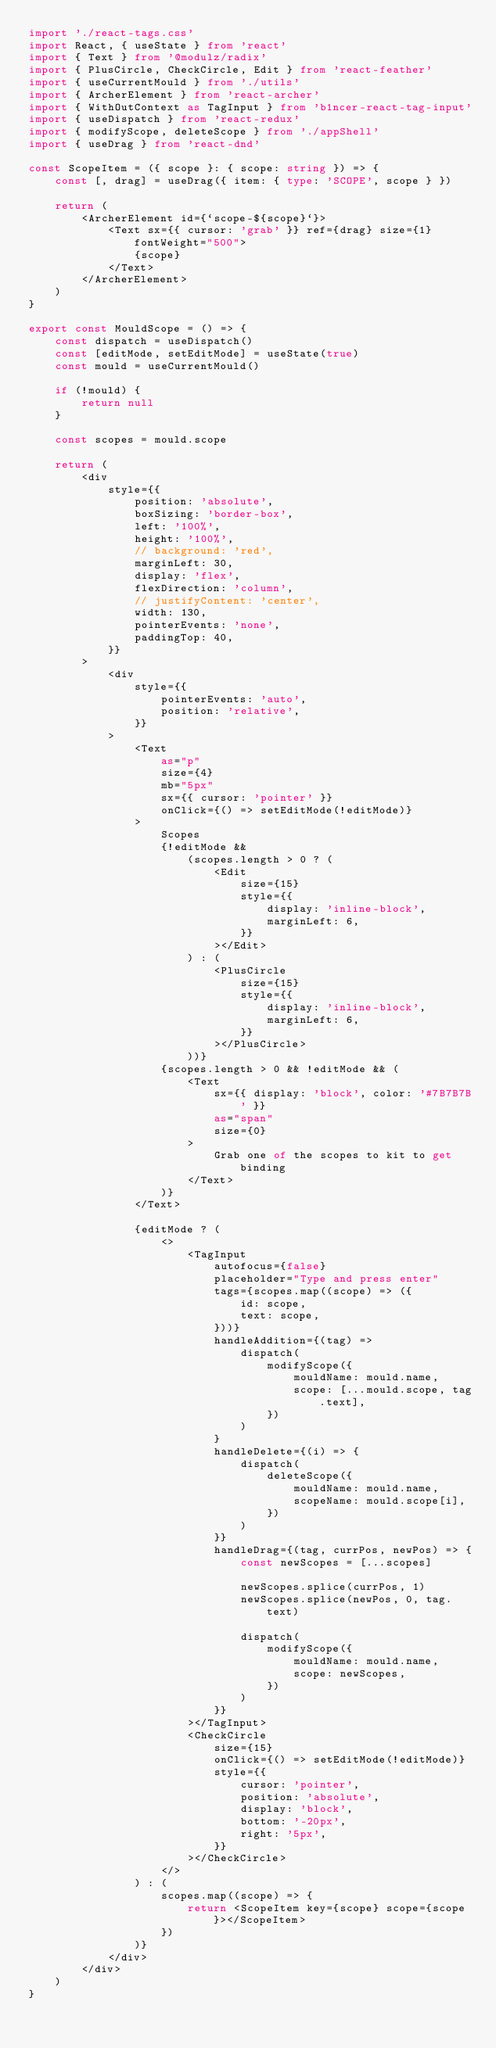<code> <loc_0><loc_0><loc_500><loc_500><_TypeScript_>import './react-tags.css'
import React, { useState } from 'react'
import { Text } from '@modulz/radix'
import { PlusCircle, CheckCircle, Edit } from 'react-feather'
import { useCurrentMould } from './utils'
import { ArcherElement } from 'react-archer'
import { WithOutContext as TagInput } from 'b1ncer-react-tag-input'
import { useDispatch } from 'react-redux'
import { modifyScope, deleteScope } from './appShell'
import { useDrag } from 'react-dnd'

const ScopeItem = ({ scope }: { scope: string }) => {
    const [, drag] = useDrag({ item: { type: 'SCOPE', scope } })

    return (
        <ArcherElement id={`scope-${scope}`}>
            <Text sx={{ cursor: 'grab' }} ref={drag} size={1} fontWeight="500">
                {scope}
            </Text>
        </ArcherElement>
    )
}

export const MouldScope = () => {
    const dispatch = useDispatch()
    const [editMode, setEditMode] = useState(true)
    const mould = useCurrentMould()

    if (!mould) {
        return null
    }

    const scopes = mould.scope

    return (
        <div
            style={{
                position: 'absolute',
                boxSizing: 'border-box',
                left: '100%',
                height: '100%',
                // background: 'red',
                marginLeft: 30,
                display: 'flex',
                flexDirection: 'column',
                // justifyContent: 'center',
                width: 130,
                pointerEvents: 'none',
                paddingTop: 40,
            }}
        >
            <div
                style={{
                    pointerEvents: 'auto',
                    position: 'relative',
                }}
            >
                <Text
                    as="p"
                    size={4}
                    mb="5px"
                    sx={{ cursor: 'pointer' }}
                    onClick={() => setEditMode(!editMode)}
                >
                    Scopes
                    {!editMode &&
                        (scopes.length > 0 ? (
                            <Edit
                                size={15}
                                style={{
                                    display: 'inline-block',
                                    marginLeft: 6,
                                }}
                            ></Edit>
                        ) : (
                            <PlusCircle
                                size={15}
                                style={{
                                    display: 'inline-block',
                                    marginLeft: 6,
                                }}
                            ></PlusCircle>
                        ))}
                    {scopes.length > 0 && !editMode && (
                        <Text
                            sx={{ display: 'block', color: '#7B7B7B' }}
                            as="span"
                            size={0}
                        >
                            Grab one of the scopes to kit to get binding
                        </Text>
                    )}
                </Text>

                {editMode ? (
                    <>
                        <TagInput
                            autofocus={false}
                            placeholder="Type and press enter"
                            tags={scopes.map((scope) => ({
                                id: scope,
                                text: scope,
                            }))}
                            handleAddition={(tag) =>
                                dispatch(
                                    modifyScope({
                                        mouldName: mould.name,
                                        scope: [...mould.scope, tag.text],
                                    })
                                )
                            }
                            handleDelete={(i) => {
                                dispatch(
                                    deleteScope({
                                        mouldName: mould.name,
                                        scopeName: mould.scope[i],
                                    })
                                )
                            }}
                            handleDrag={(tag, currPos, newPos) => {
                                const newScopes = [...scopes]

                                newScopes.splice(currPos, 1)
                                newScopes.splice(newPos, 0, tag.text)

                                dispatch(
                                    modifyScope({
                                        mouldName: mould.name,
                                        scope: newScopes,
                                    })
                                )
                            }}
                        ></TagInput>
                        <CheckCircle
                            size={15}
                            onClick={() => setEditMode(!editMode)}
                            style={{
                                cursor: 'pointer',
                                position: 'absolute',
                                display: 'block',
                                bottom: '-20px',
                                right: '5px',
                            }}
                        ></CheckCircle>
                    </>
                ) : (
                    scopes.map((scope) => {
                        return <ScopeItem key={scope} scope={scope}></ScopeItem>
                    })
                )}
            </div>
        </div>
    )
}
</code> 